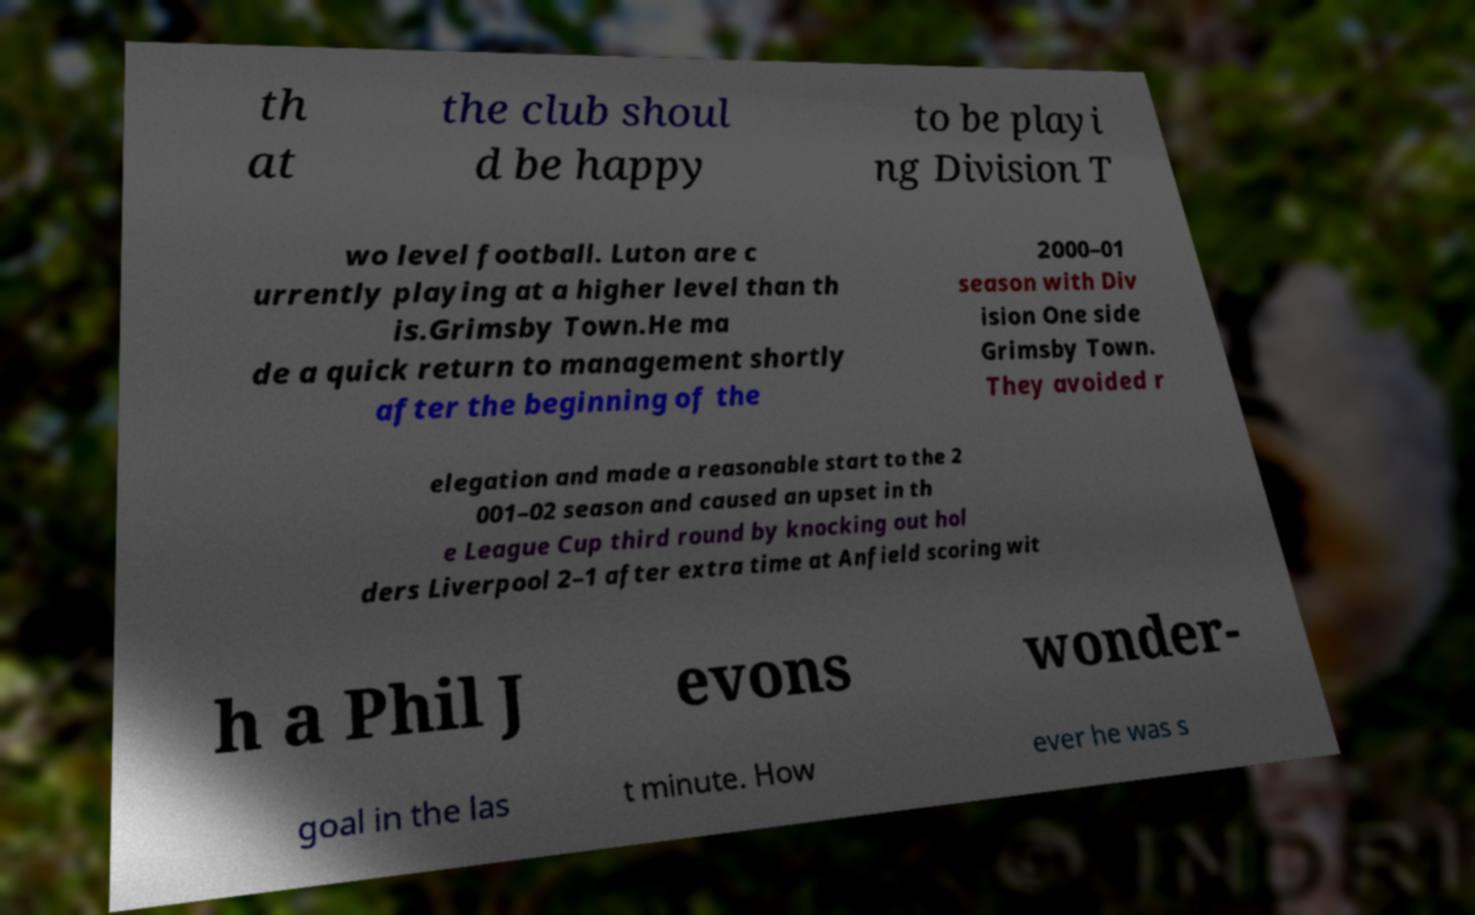Please read and relay the text visible in this image. What does it say? th at the club shoul d be happy to be playi ng Division T wo level football. Luton are c urrently playing at a higher level than th is.Grimsby Town.He ma de a quick return to management shortly after the beginning of the 2000–01 season with Div ision One side Grimsby Town. They avoided r elegation and made a reasonable start to the 2 001–02 season and caused an upset in th e League Cup third round by knocking out hol ders Liverpool 2–1 after extra time at Anfield scoring wit h a Phil J evons wonder- goal in the las t minute. How ever he was s 